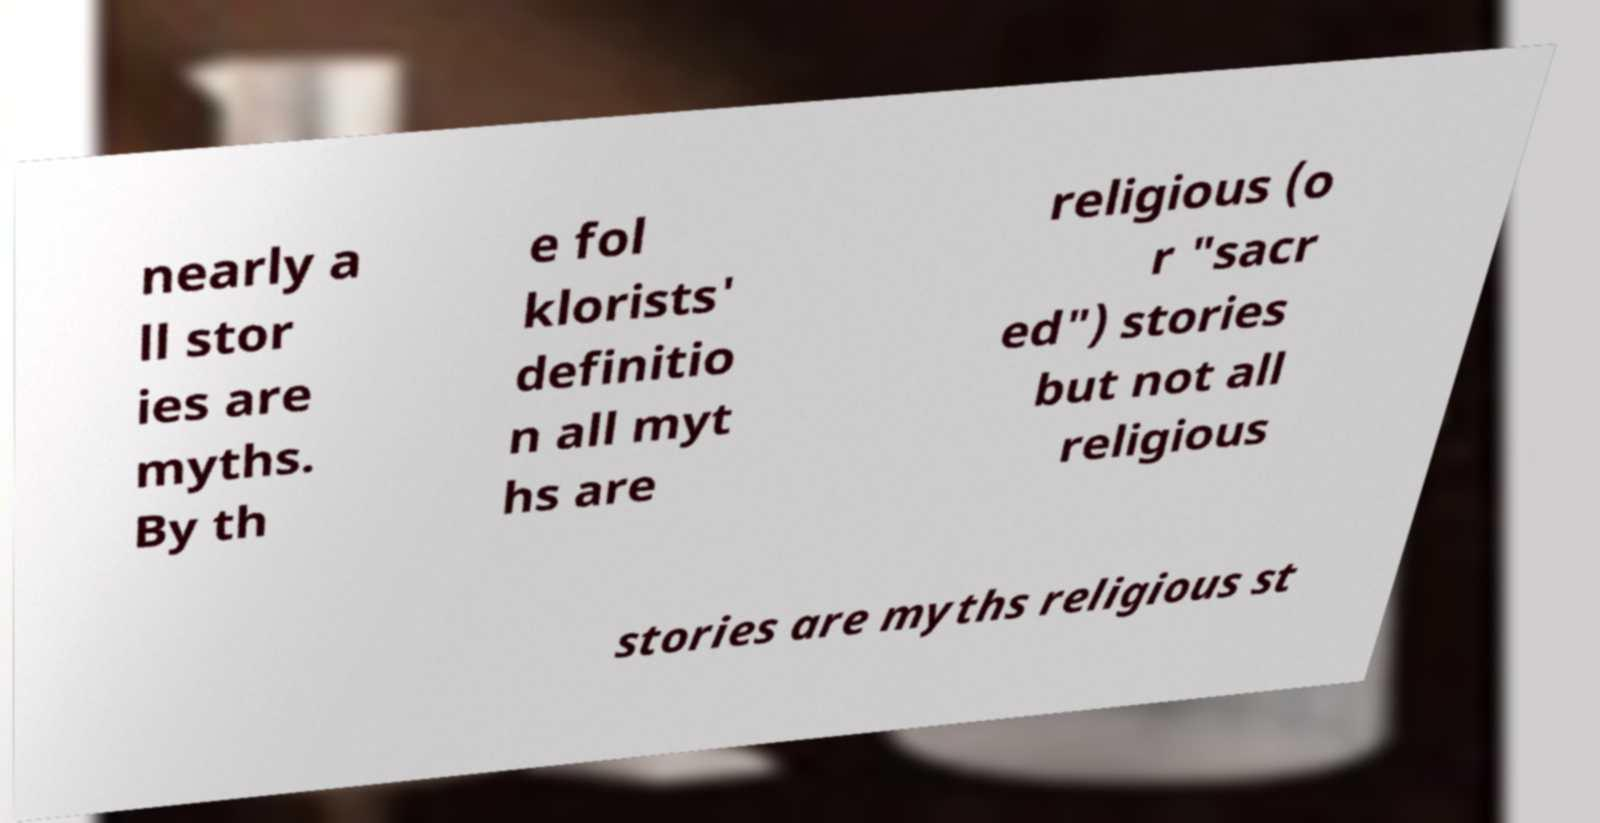Could you extract and type out the text from this image? nearly a ll stor ies are myths. By th e fol klorists' definitio n all myt hs are religious (o r "sacr ed") stories but not all religious stories are myths religious st 